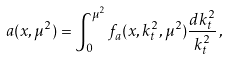<formula> <loc_0><loc_0><loc_500><loc_500>a ( x , \mu ^ { 2 } ) = \int _ { 0 } ^ { \mu ^ { 2 } } f _ { a } ( x , k _ { t } ^ { 2 } , \mu ^ { 2 } ) \frac { d k _ { t } ^ { 2 } } { k _ { t } ^ { 2 } } \, ,</formula> 